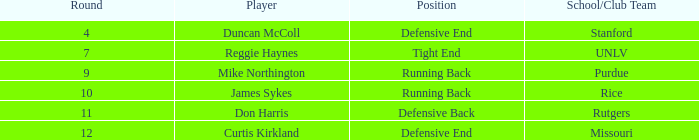What is the highest round number for the player who came from team Missouri? 12.0. 